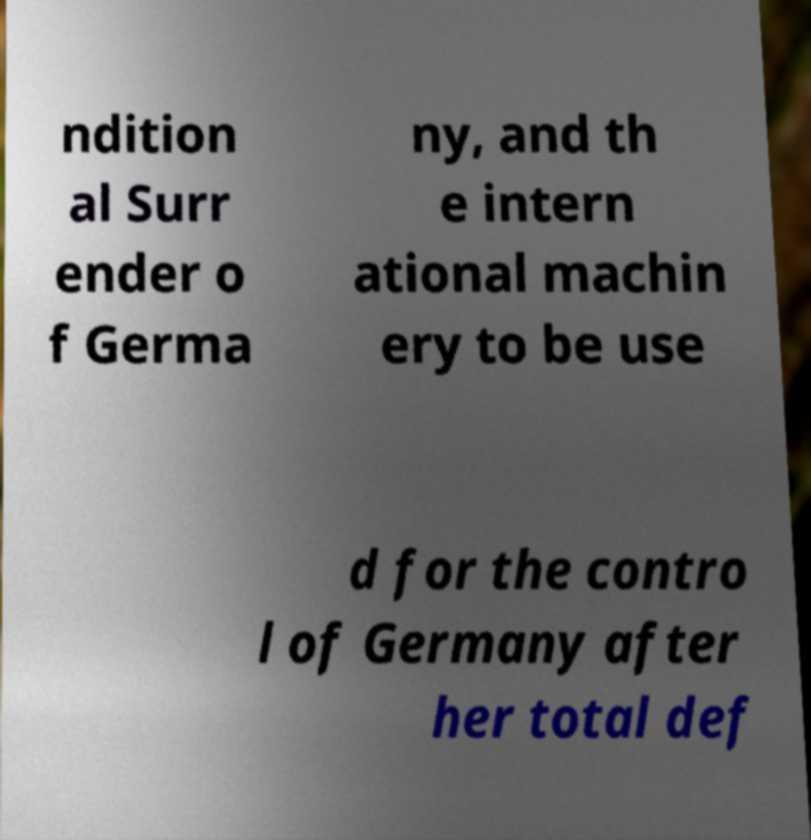Can you read and provide the text displayed in the image?This photo seems to have some interesting text. Can you extract and type it out for me? ndition al Surr ender o f Germa ny, and th e intern ational machin ery to be use d for the contro l of Germany after her total def 